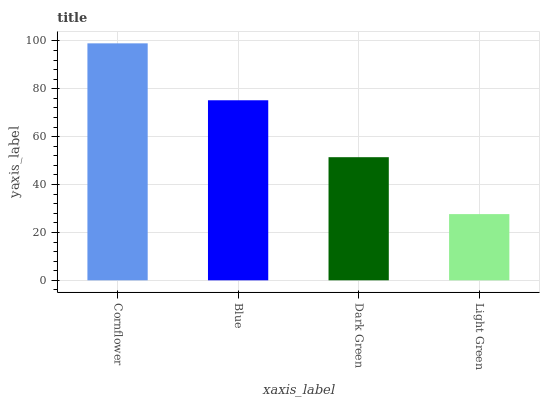Is Light Green the minimum?
Answer yes or no. Yes. Is Cornflower the maximum?
Answer yes or no. Yes. Is Blue the minimum?
Answer yes or no. No. Is Blue the maximum?
Answer yes or no. No. Is Cornflower greater than Blue?
Answer yes or no. Yes. Is Blue less than Cornflower?
Answer yes or no. Yes. Is Blue greater than Cornflower?
Answer yes or no. No. Is Cornflower less than Blue?
Answer yes or no. No. Is Blue the high median?
Answer yes or no. Yes. Is Dark Green the low median?
Answer yes or no. Yes. Is Dark Green the high median?
Answer yes or no. No. Is Cornflower the low median?
Answer yes or no. No. 